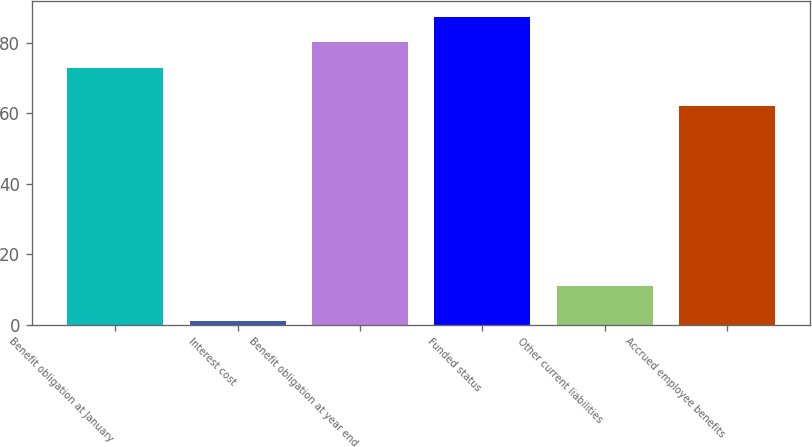<chart> <loc_0><loc_0><loc_500><loc_500><bar_chart><fcel>Benefit obligation at January<fcel>Interest cost<fcel>Benefit obligation at year end<fcel>Funded status<fcel>Other current liabilities<fcel>Accrued employee benefits<nl><fcel>73<fcel>1<fcel>80.2<fcel>87.4<fcel>11<fcel>62<nl></chart> 